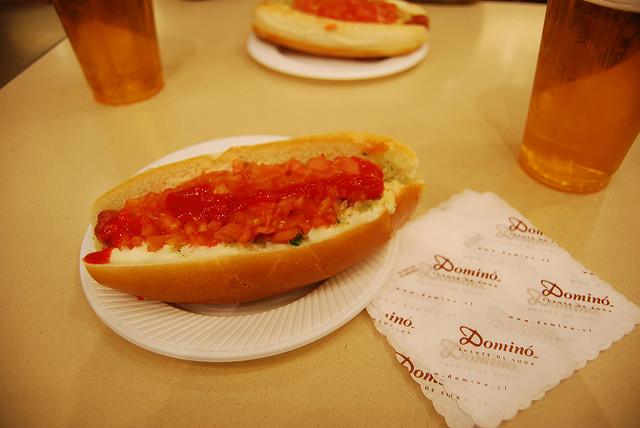What is printed on the napkin?
Keep it brief. Domino. Is this food healthy?
Give a very brief answer. No. What is in the glasses?
Short answer required. Beer. 